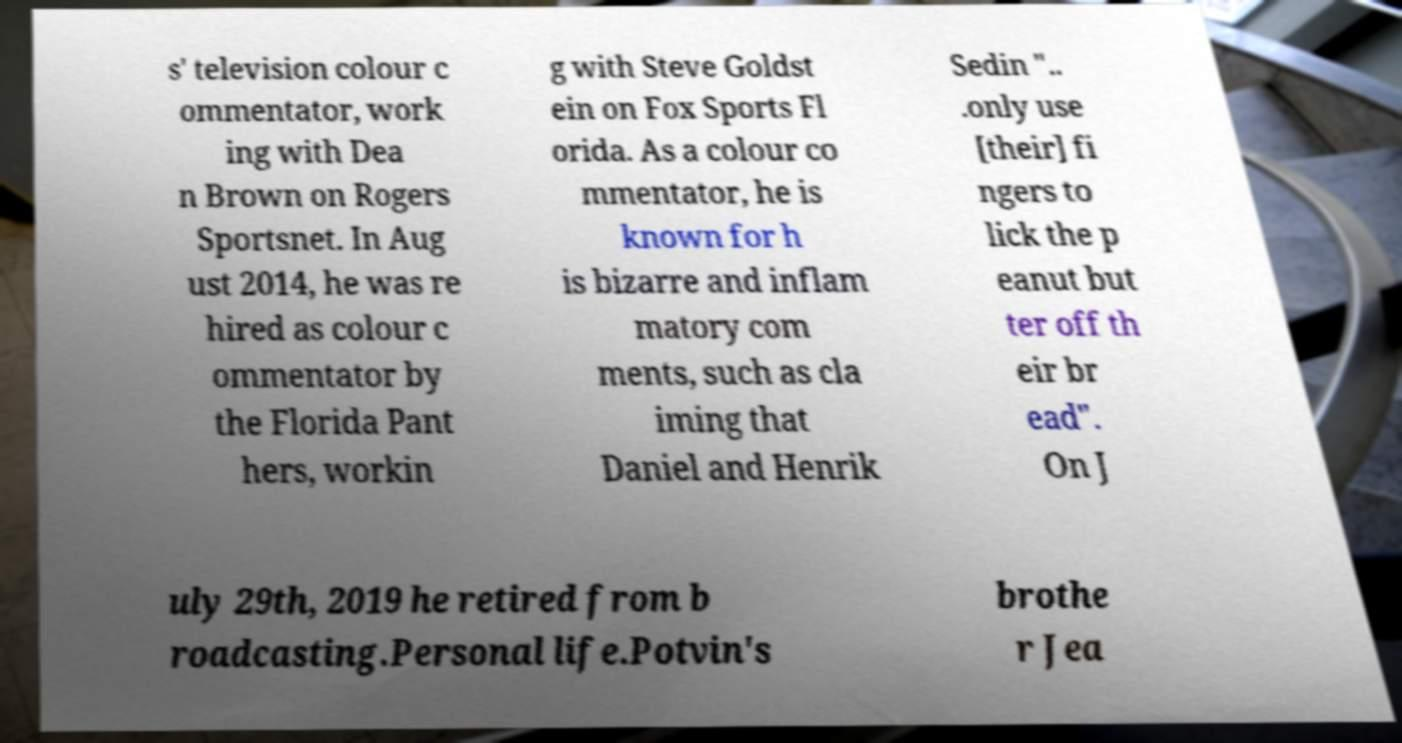There's text embedded in this image that I need extracted. Can you transcribe it verbatim? s' television colour c ommentator, work ing with Dea n Brown on Rogers Sportsnet. In Aug ust 2014, he was re hired as colour c ommentator by the Florida Pant hers, workin g with Steve Goldst ein on Fox Sports Fl orida. As a colour co mmentator, he is known for h is bizarre and inflam matory com ments, such as cla iming that Daniel and Henrik Sedin ".. .only use [their] fi ngers to lick the p eanut but ter off th eir br ead". On J uly 29th, 2019 he retired from b roadcasting.Personal life.Potvin's brothe r Jea 